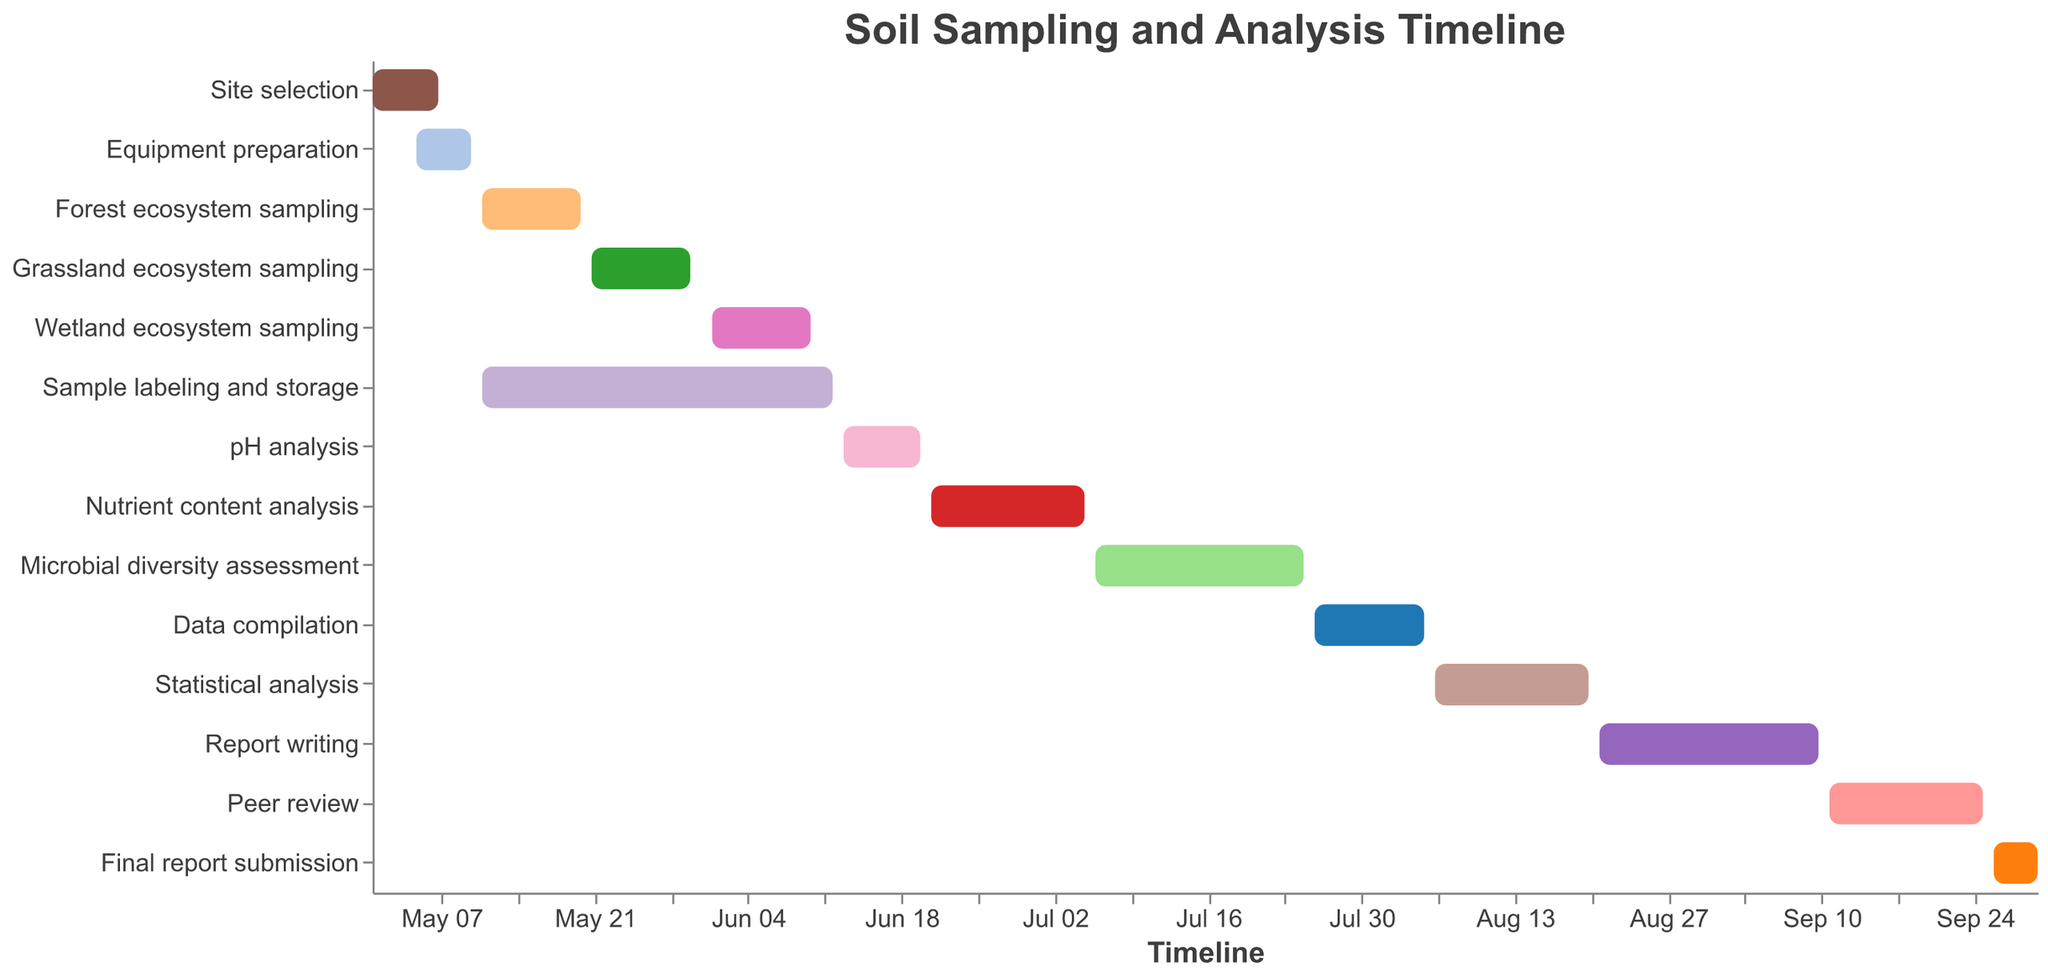What task is the first one on the timeline? The first task is the one that appears earliest on the timeline. According to the Gantt Chart, "Site selection" starts on 2023-05-01.
Answer: Site selection What is the duration of the "Grassland ecosystem sampling" task? To find the duration, subtract the start date from the end date. The "Grassland ecosystem sampling" starts on 2023-05-21 and ends on 2023-05-30, so its duration is 10 days.
Answer: 10 days Which tasks are simultaneously executed during the "Forest ecosystem sampling"? The "Forest ecosystem sampling" runs from 2023-05-11 to 2023-05-20. Any tasks within this timeframe are simultaneously executed. According to the chart, "Sample labeling and storage" (2023-05-11 to 2023-06-12) overlaps with it.
Answer: Sample labeling and storage Between which two tasks is there the shortest gap on the timeline? To find the shortest gap, calculate the difference in start dates between consecutive tasks. The gap between "Grassland ecosystem sampling" ending on 2023-05-30 and "Wetland ecosystem sampling" starting on 2023-06-01 is the shortest, which is 1 day.
Answer: Grassland ecosystem sampling and Wetland ecosystem sampling When does the "Report writing" task end? The "Report writing" task ends on 2023-09-10 as indicated on the timeline.
Answer: 2023-09-10 What tasks need to be completed before the "pH analysis" can start? By examining the timeline, "pH analysis" starts on 2023-06-13. Thus, any tasks ending before this date are prerequisites, which include "Site selection", "Equipment preparation", "Forest ecosystem sampling", "Grassland ecosystem sampling", "Wetland ecosystem sampling", and "Sample labeling and storage".
Answer: Site selection, Equipment preparation, Forest ecosystem sampling, Grassland ecosystem sampling, Wetland ecosystem sampling, Sample labeling and storage How many tasks are there in total? Count the number of distinct tasks listed on the timeline. There are 14 tasks in total.
Answer: 14 Which task has the longest duration? To determine the longest duration, compare the length of time each task spans. "Sample labeling and storage", from 2023-05-11 to 2023-06-12, has the longest duration, lasting 33 days.
Answer: Sample labeling and storage What is the last task on the Gantt Chart and its duration? The last task appears at the end of the timeline. "Final report submission" runs from 2023-09-26 to 2023-09-30. Its duration is 5 days.
Answer: Final report submission, 5 days 